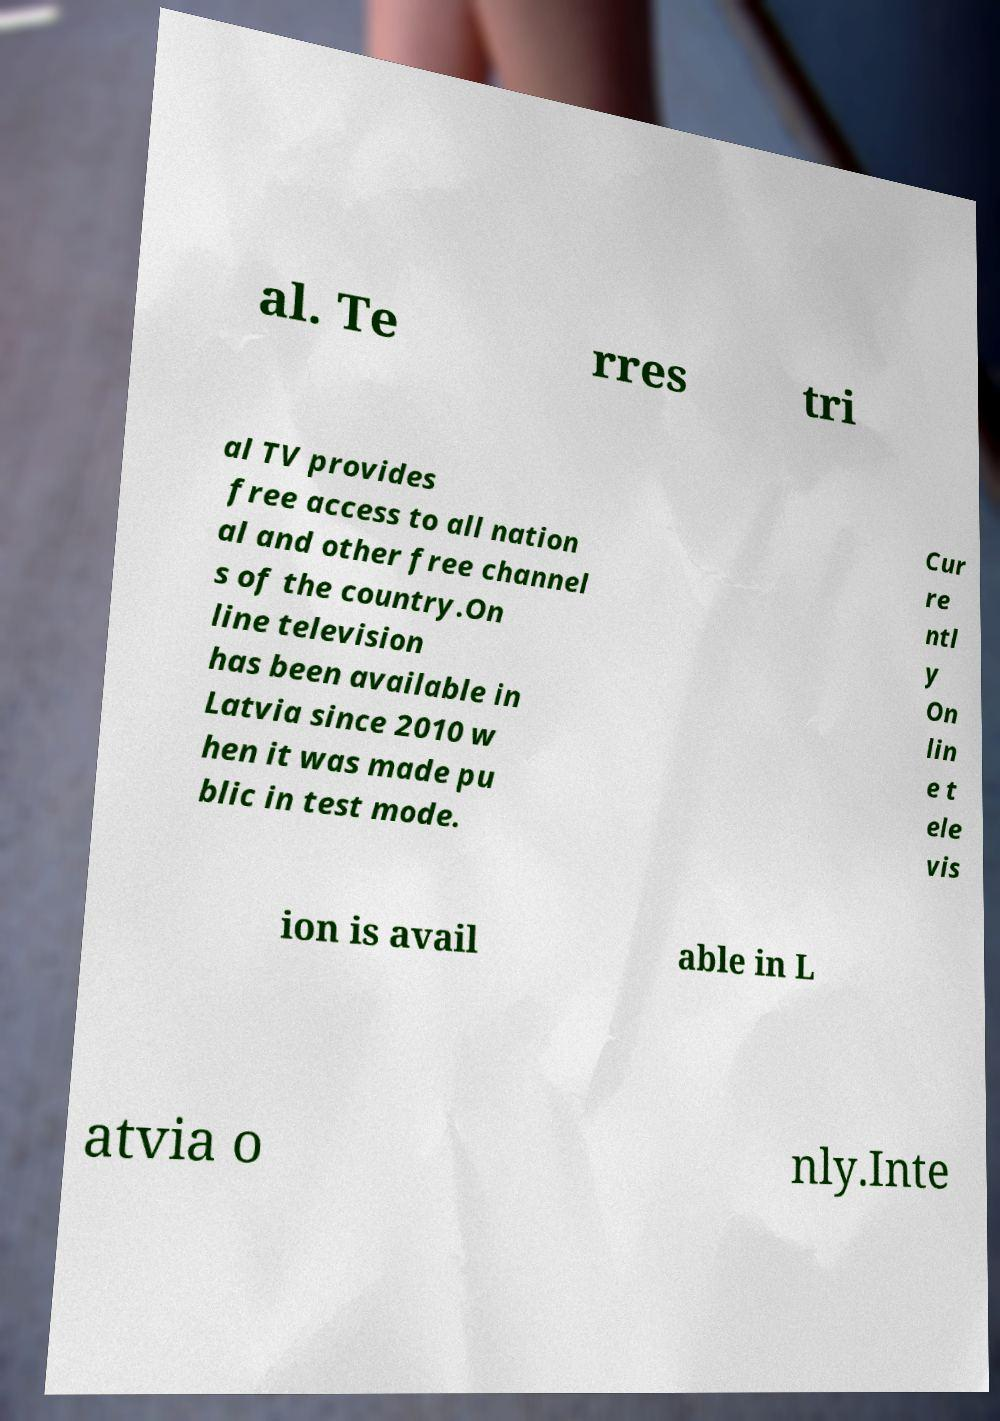I need the written content from this picture converted into text. Can you do that? al. Te rres tri al TV provides free access to all nation al and other free channel s of the country.On line television has been available in Latvia since 2010 w hen it was made pu blic in test mode. Cur re ntl y On lin e t ele vis ion is avail able in L atvia o nly.Inte 